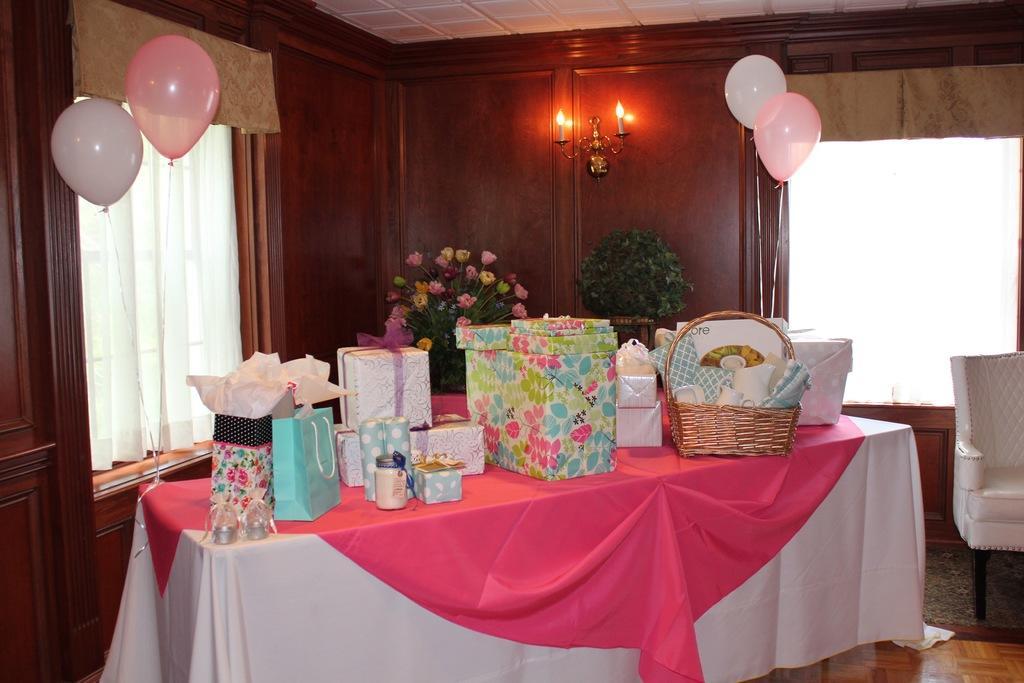In one or two sentences, can you explain what this image depicts? This picture shows an inner view of the room. White color ceiling in that room. Two windows covered with two window curtains. Wooden cupboards are there, candle light set is attached in that wooden cupboard. Small plant pot is there. One chair is there, one mat is under the chair. One table is covered with white and pink color clothes. One flower pot is on the table and Some gifts, one bottle and some objects are on that table. 